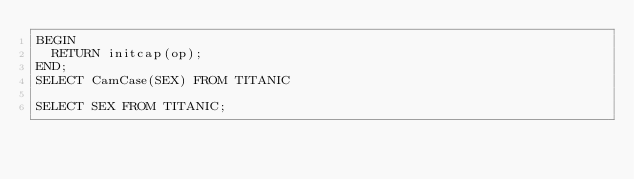Convert code to text. <code><loc_0><loc_0><loc_500><loc_500><_SQL_>BEGIN
  RETURN initcap(op);
END;
SELECT CamCase(SEX) FROM TITANIC

SELECT SEX FROM TITANIC;</code> 